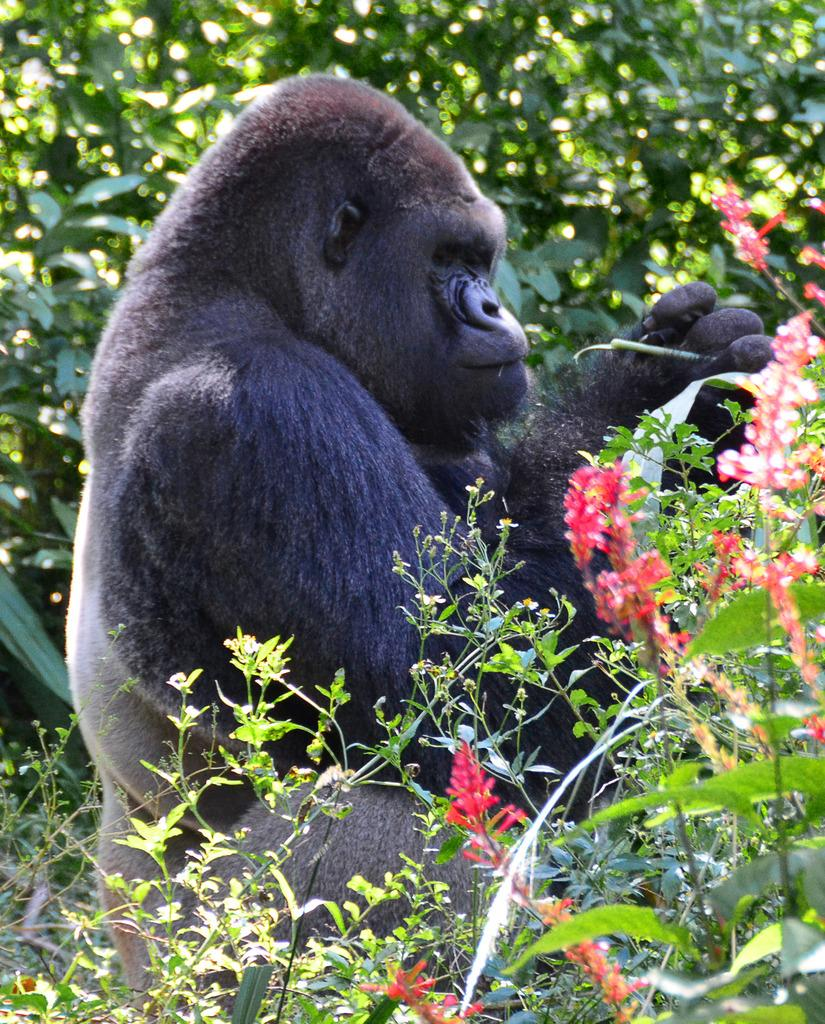What animal is in the image? There is a gorilla in the image. Where is the gorilla located? The gorilla is on the ground. What is covering the ground in the image? The ground is covered with flower plants. What type of vegetation can be seen in the image? Trees are present in the image. How many matches are scattered on the ground in the image? There are no matches present in the image; it features a gorilla on the ground covered with flower plants. What type of goat can be seen grazing near the trees in the image? There is no goat present in the image; it features a gorilla and trees. 